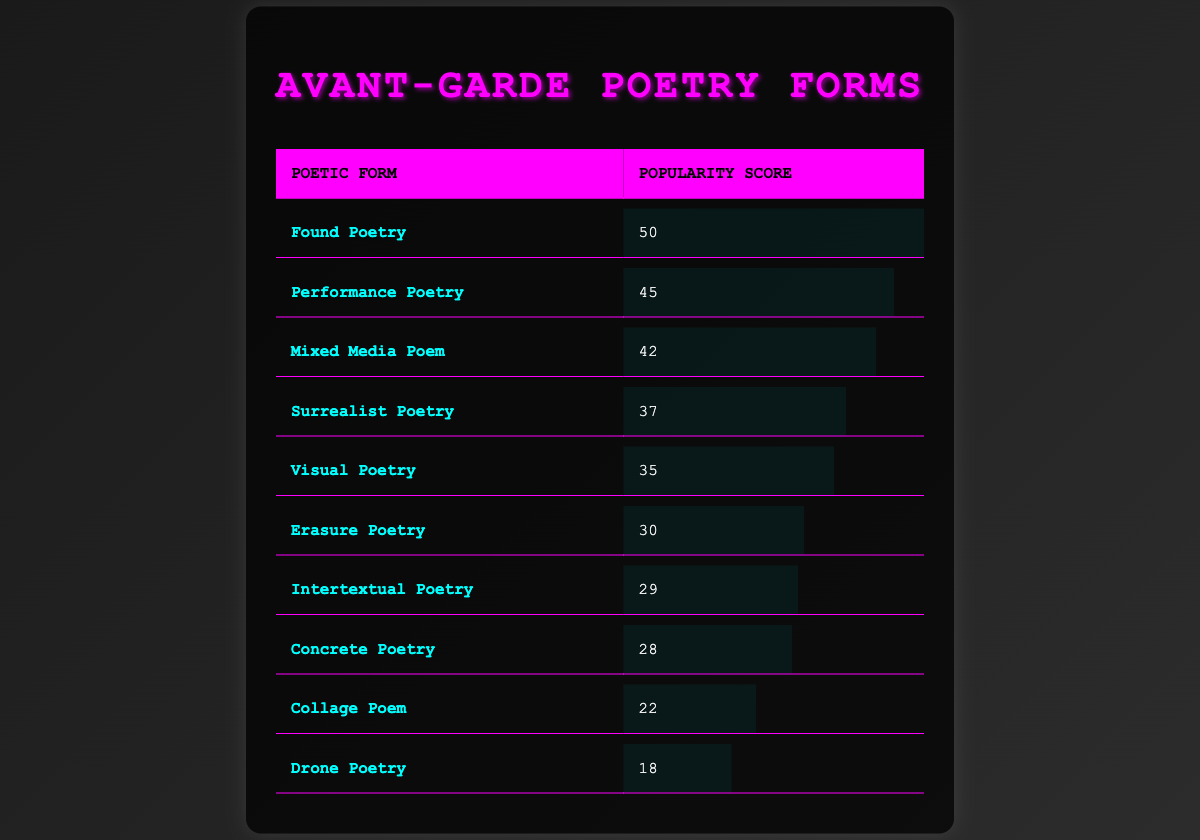What is the popularity score of Found Poetry? Found Poetry's popularity score is directly listed in the table as 50.
Answer: 50 Which poetic form has the lowest popularity score? The lowest popularity score can be found by comparing all the values in the popularity column; Drone Poetry has the lowest score of 18.
Answer: Drone Poetry What is the average popularity score of the poetic forms? To find the average, add all popularity scores: 50 + 45 + 42 + 37 + 35 + 30 + 29 + 28 + 22 + 18 =  366. There are 10 forms, so the average is 366/10 = 36.6.
Answer: 36.6 Is Performance Poetry more popular than Visual Poetry? Comparing the popularity scores, Performance Poetry has a score of 45, while Visual Poetry’s score is 35. Thus, Performance Poetry is indeed more popular than Visual Poetry.
Answer: Yes What is the total popularity score of Mixed Media Poem, Surrealist Poetry, and Erasure Poetry combined? The combined score is calculated by adding the three forms' scores: Mixed Media Poem (42) + Surrealist Poetry (37) + Erasure Poetry (30) = 109.
Answer: 109 Which poetic forms have a popularity score above 30? By examining the table, the forms with scores above 30 are: Found Poetry (50), Performance Poetry (45), Mixed Media Poem (42), Surrealist Poetry (37), Visual Poetry (35), and Erasure Poetry (30).
Answer: Found Poetry, Performance Poetry, Mixed Media Poem, Surrealist Poetry, Visual Poetry, Erasure Poetry What is the difference in popularity score between the most popular and the least popular poetic forms? The most popular form is Found Poetry with a score of 50, and the least popular is Drone Poetry with a score of 18. The difference is calculated as 50 - 18 = 32.
Answer: 32 How many poetic forms have a popularity score between 20 and 40? The forms within that range are Mixed Media Poem (42), Surrealist Poetry (37), Visual Poetry (35), and Erasure Poetry (30), along with Intertextual Poetry (29) and Concrete Poetry (28). Counting these gives us 6 forms.
Answer: 6 Is Erasure Poetry less popular than Concrete Poetry? Erasure Poetry has a popularity score of 30, while Concrete Poetry has a score of 28. Therefore, Erasure Poetry is more popular than Concrete Poetry.
Answer: No 